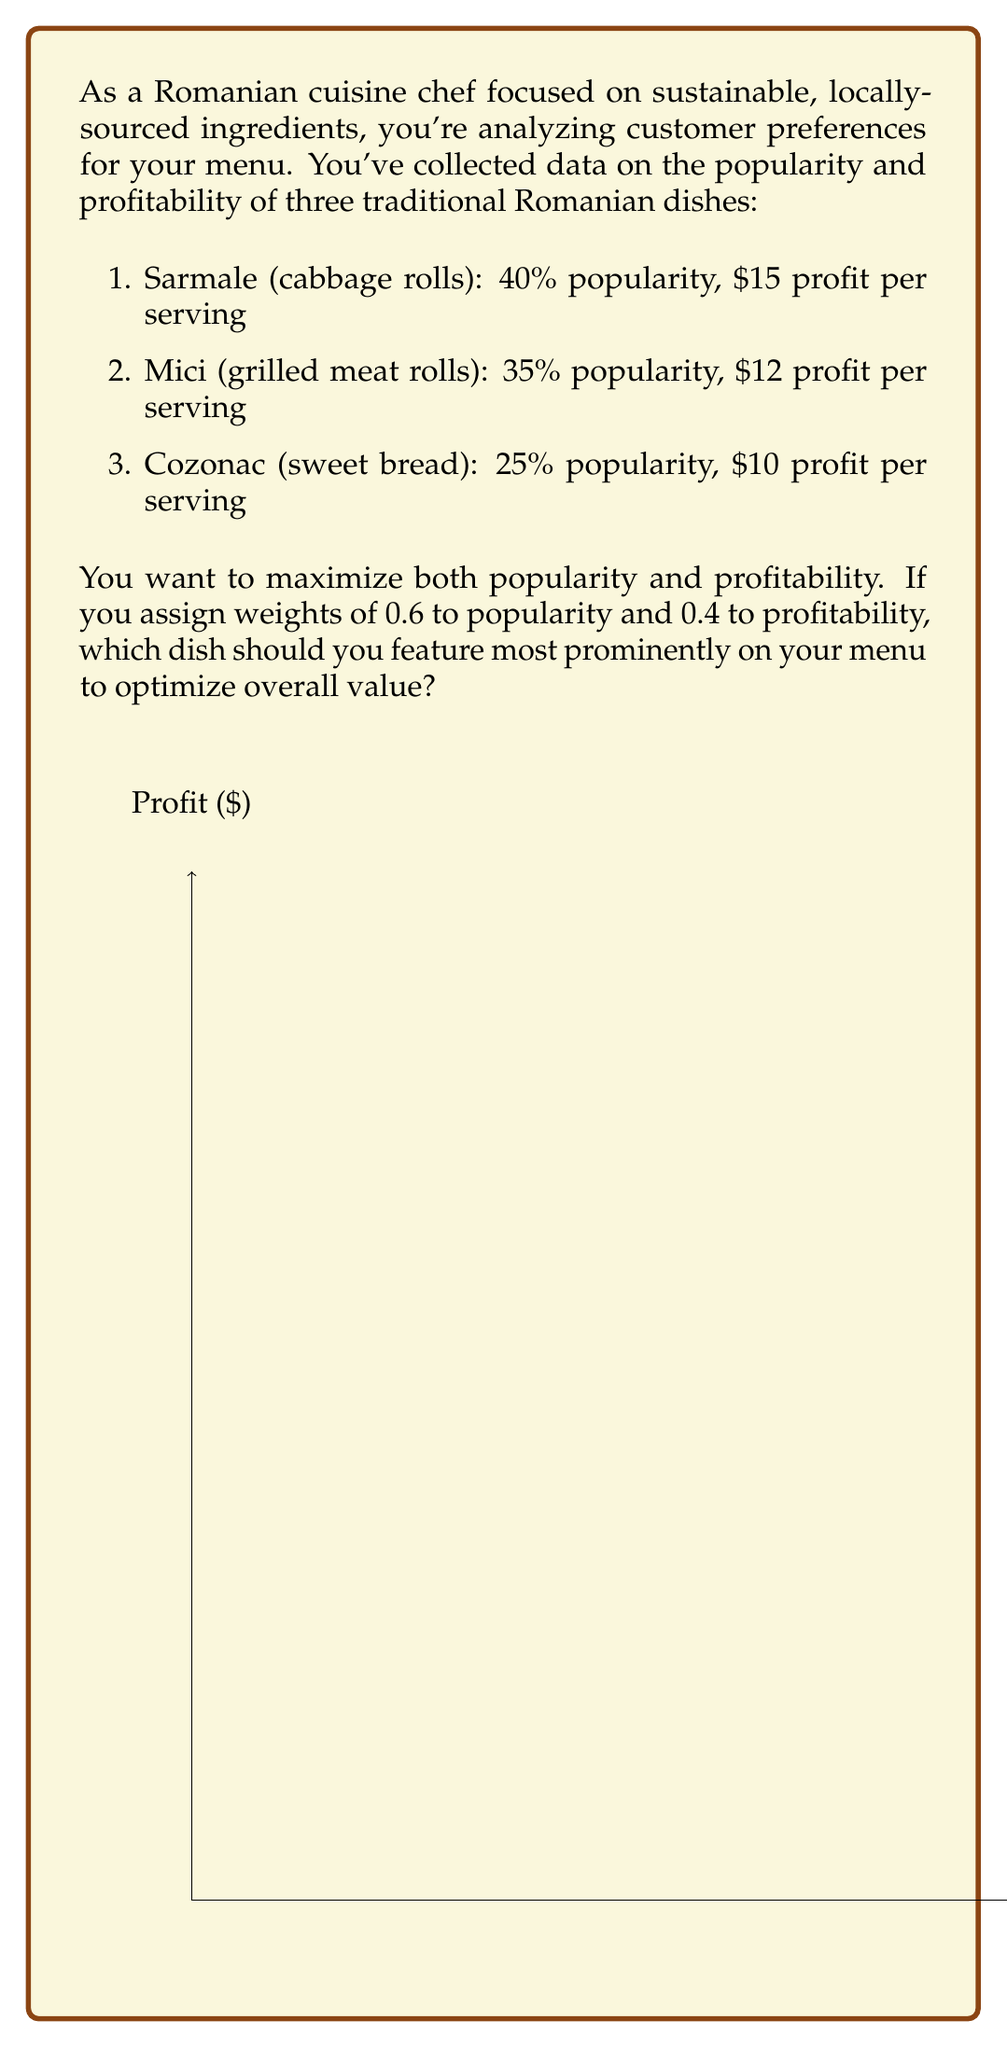Give your solution to this math problem. To solve this problem, we need to calculate a weighted score for each dish based on both popularity and profitability. Let's follow these steps:

1. Normalize the popularity and profit values to a 0-1 scale:
   Popularity: Sarmale (0.4), Mici (0.35), Cozonac (0.25)
   Profit: Sarmale (1), Mici (0.8), Cozonac (0.667)

2. Calculate the weighted score for each dish using the formula:
   $Score = 0.6 \times Normalized Popularity + 0.4 \times Normalized Profit$

   Sarmale: $0.6 \times 0.4 + 0.4 \times 1 = 0.24 + 0.4 = 0.64$
   Mici: $0.6 \times 0.35 + 0.4 \times 0.8 = 0.21 + 0.32 = 0.53$
   Cozonac: $0.6 \times 0.25 + 0.4 \times 0.667 = 0.15 + 0.2668 = 0.4168$

3. Compare the scores:
   Sarmale: 0.64
   Mici: 0.53
   Cozonac: 0.4168

The highest score is for Sarmale (cabbage rolls) at 0.64, indicating that it offers the best balance of popularity and profitability given the assigned weights.
Answer: Sarmale (cabbage rolls) 